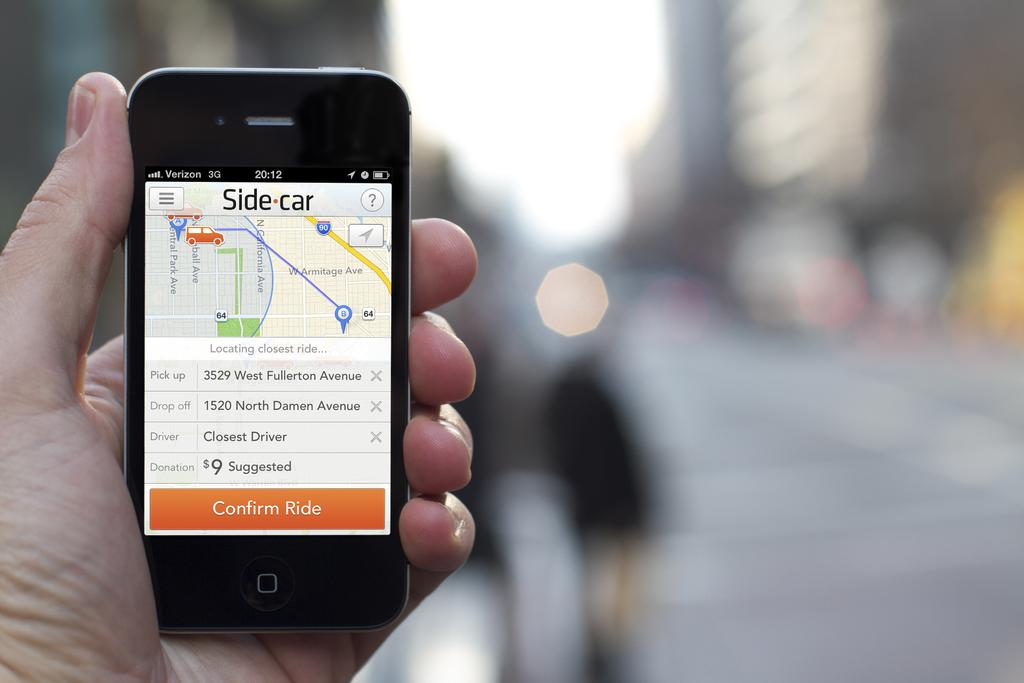<image>
Render a clear and concise summary of the photo. A Verizon phone open to an app called Side Car. 